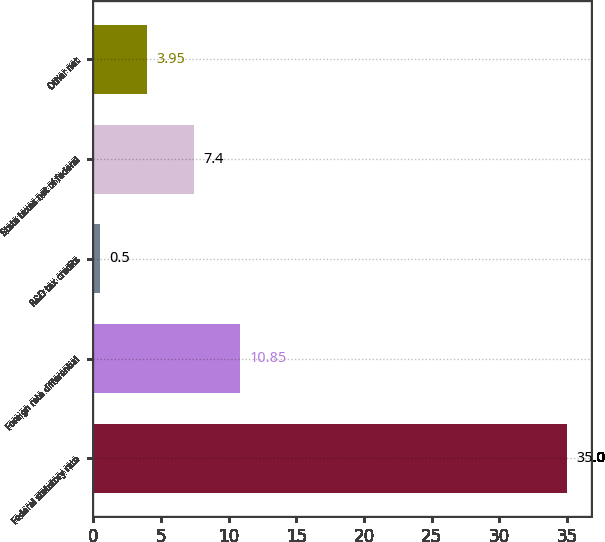<chart> <loc_0><loc_0><loc_500><loc_500><bar_chart><fcel>Federal statutory rate<fcel>Foreign rate differential<fcel>R&D tax credits<fcel>State taxes net of federal<fcel>Other net<nl><fcel>35<fcel>10.85<fcel>0.5<fcel>7.4<fcel>3.95<nl></chart> 